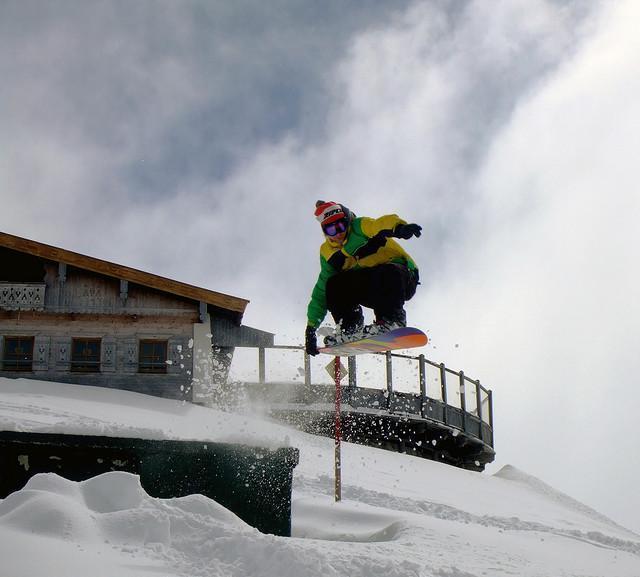How many people are in the picture?
Give a very brief answer. 1. How many plates have a sandwich on it?
Give a very brief answer. 0. 